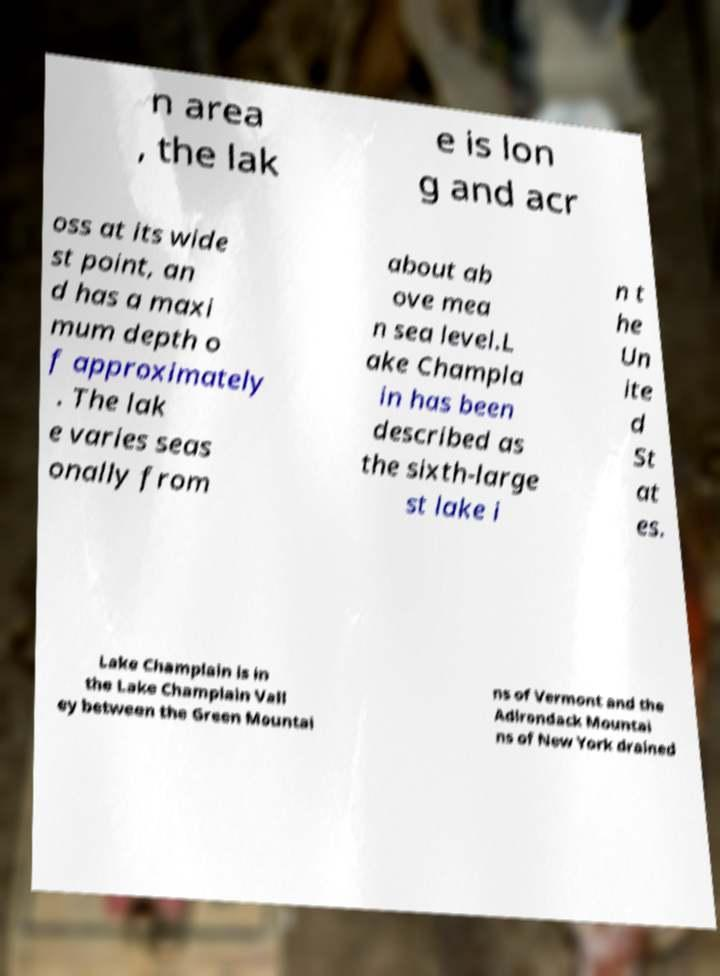For documentation purposes, I need the text within this image transcribed. Could you provide that? n area , the lak e is lon g and acr oss at its wide st point, an d has a maxi mum depth o f approximately . The lak e varies seas onally from about ab ove mea n sea level.L ake Champla in has been described as the sixth-large st lake i n t he Un ite d St at es. Lake Champlain is in the Lake Champlain Vall ey between the Green Mountai ns of Vermont and the Adirondack Mountai ns of New York drained 